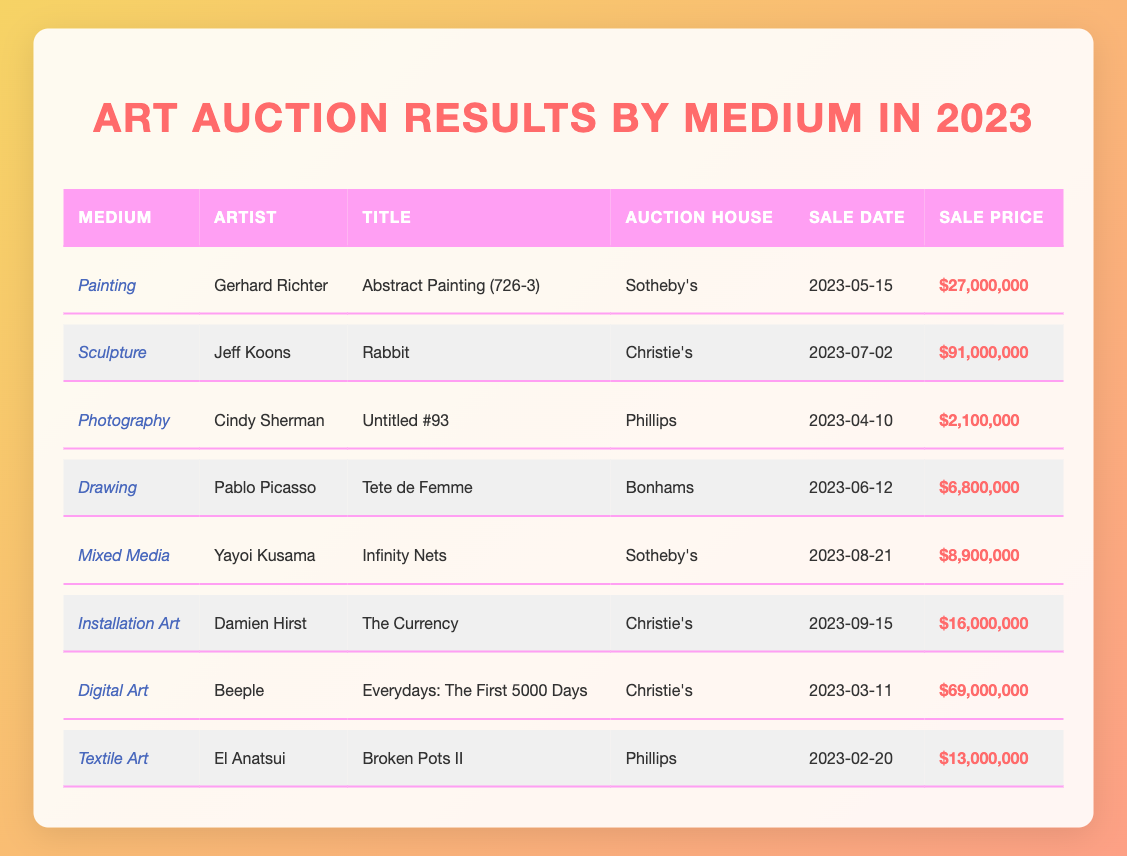What was the highest sale price for an artwork in 2023? The highest sale price is found in the "Sale Price" column. Scanning through the prices, the highest value is $91,000,000 for Jeff Koons' "Rabbit."
Answer: $91,000,000 Which artist sold an artwork titled "Infinity Nets"? By looking at the "Title" column, "Infinity Nets" corresponds to Yayoi Kusama, as shown in the "Artist" column.
Answer: Yayoi Kusama How many artworks sold for more than $20 million? The "Sale Price" column shows three artworks above $20 million: Gerhard Richter with $27,000,000 and Jeff Koons with $91,000,000, and Beeple's digital art sold for $69,000,000, totaling three.
Answer: 3 What is the average sale price of the artworks in this table? To find the average sale price: First, add all the sale prices: 27,000,000 + 91,000,000 + 2,100,000 + 6,800,000 + 8,900,000 + 16,000,000 + 69,000,000 + 13,000,000 = 233,800,000. Next, divide this sum by the number of artworks (8): 233,800,000 / 8 = 29,225,000.
Answer: 29,225,000 Did any artwork sell for less than $5 million? To answer, check the "Sale Price" column for values under $5 million. Looking through the entries, the lowest price is $2,100,000 for Cindy Sherman's "Untitled #93," confirming that yes, there was an artwork sold for less than $5 million.
Answer: Yes Which medium type had the most expensive artwork in this auction round? To find the medium type with the highest sale price, review the "Medium" column alongside the highest sale price of $91,000,000, which is under the medium "Sculpture." Thus, "Sculpture" holds the most expensive artwork.
Answer: Sculpture What percentage of artworks were sold by Christie's? First, count the total number of artworks (8) and how many were sold by Christie's (3). Calculate the percentage by dividing 3 by 8 and multiplying by 100: (3/8) * 100 = 37.5%.
Answer: 37.5% Is "Digital Art" listed as a medium in the results? Simply look for "Digital Art" in the "Medium" column. It's present, confirmed by Beeple's artwork listed under that medium, affirming the answer is yes.
Answer: Yes 